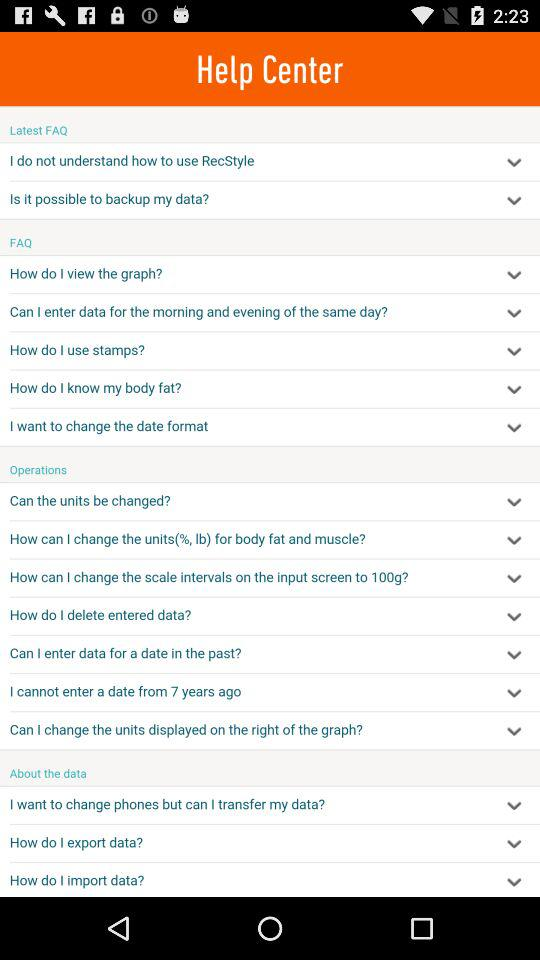What are the operations done in the help center? The operations are "Can the units be changed?", "How can I change the units(%, lb) for body fat and muscle?", "How can I change the scale intervals on the input screen to 100g?", "How do I delete entered data?", "Can I enter data for a date in the past?", "I cannot enter a date from 7 years ago" and "Can I change the units displayed on the right of the graph?". 